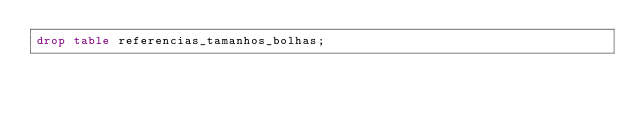<code> <loc_0><loc_0><loc_500><loc_500><_SQL_>drop table referencias_tamanhos_bolhas;</code> 